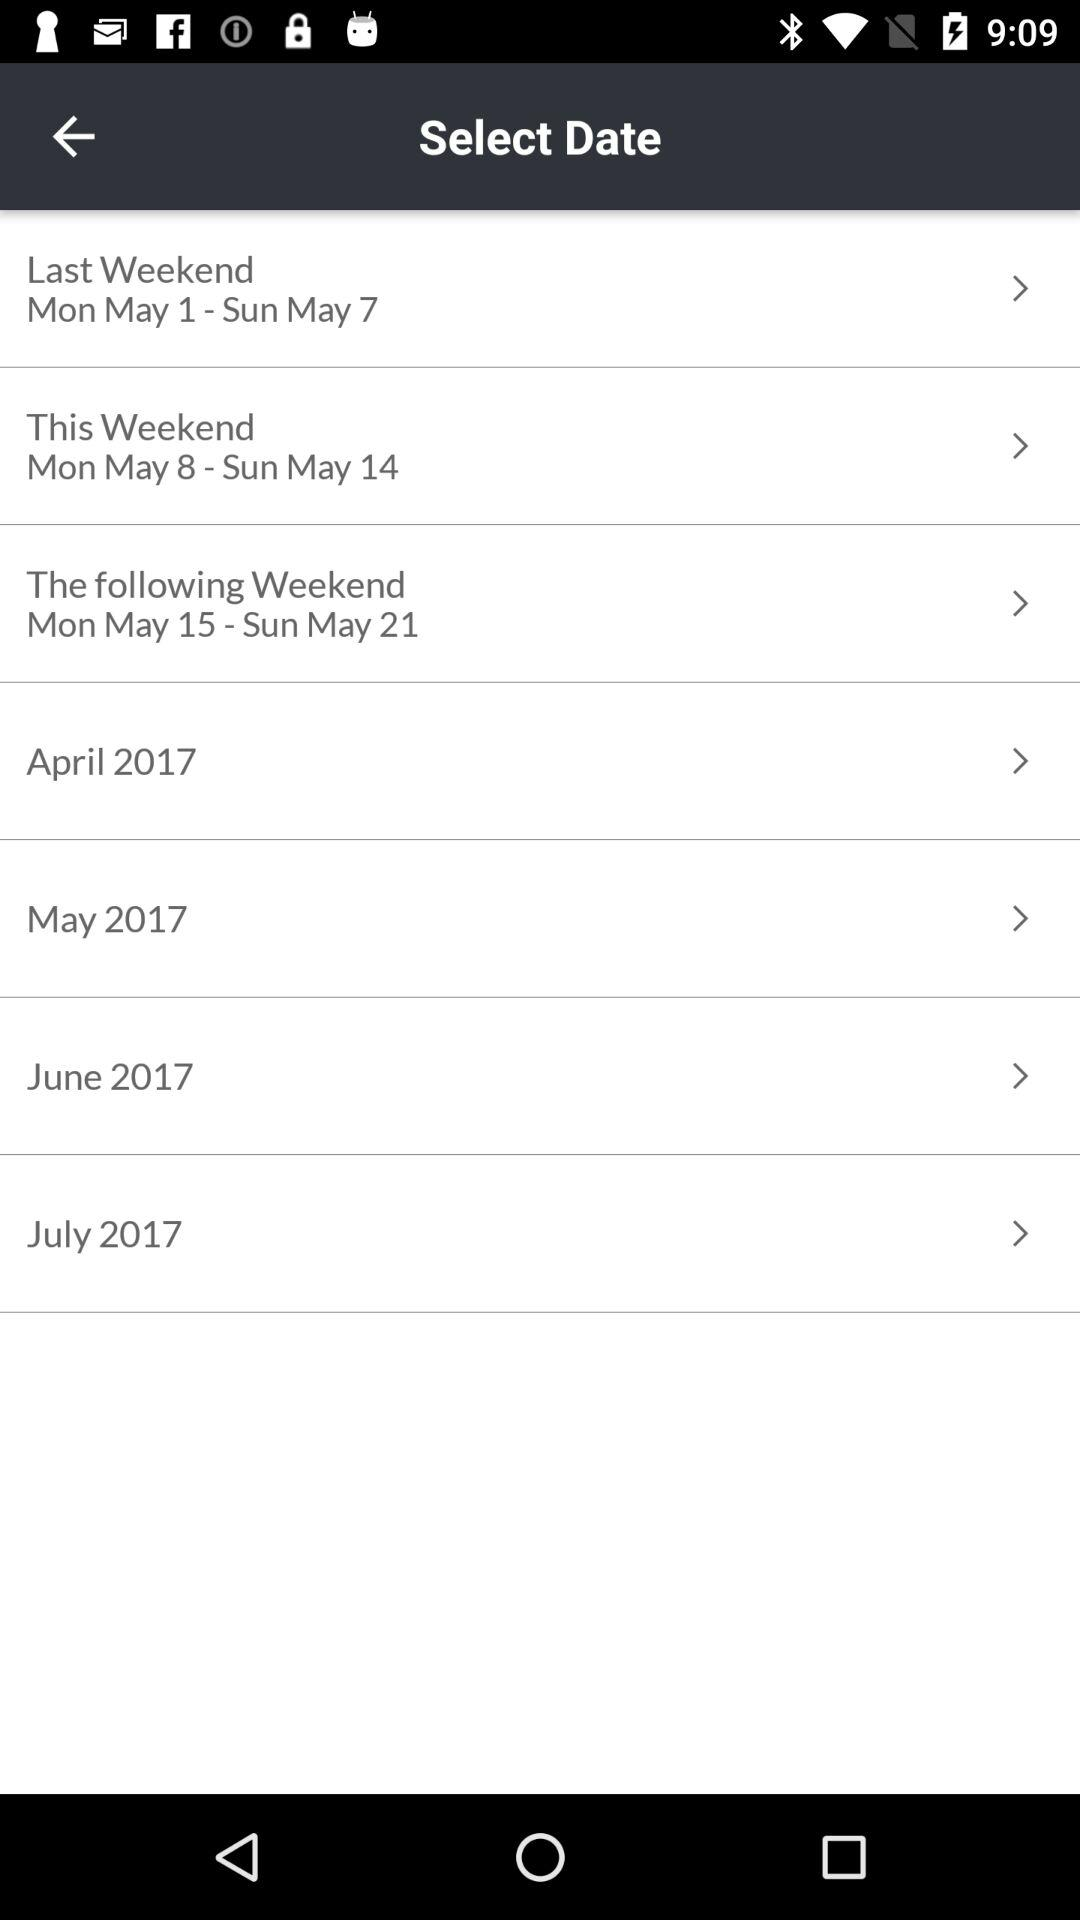To what category does the date range from May 1 to May 7 belong? The category is "Last Weekend". 